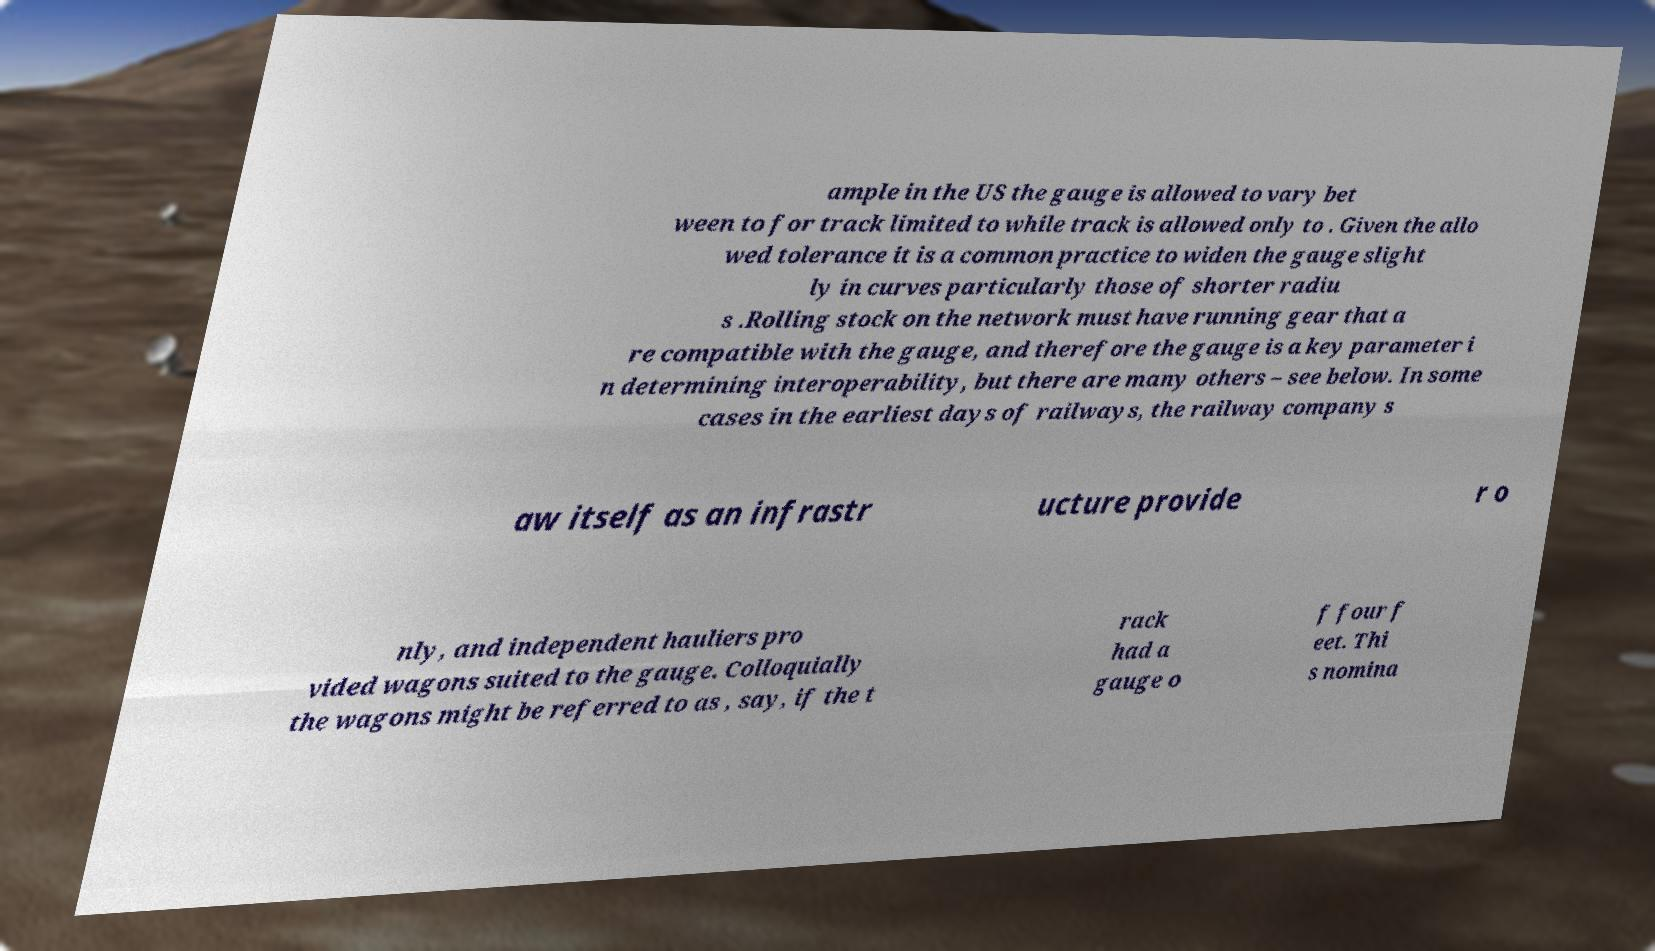Can you accurately transcribe the text from the provided image for me? ample in the US the gauge is allowed to vary bet ween to for track limited to while track is allowed only to . Given the allo wed tolerance it is a common practice to widen the gauge slight ly in curves particularly those of shorter radiu s .Rolling stock on the network must have running gear that a re compatible with the gauge, and therefore the gauge is a key parameter i n determining interoperability, but there are many others – see below. In some cases in the earliest days of railways, the railway company s aw itself as an infrastr ucture provide r o nly, and independent hauliers pro vided wagons suited to the gauge. Colloquially the wagons might be referred to as , say, if the t rack had a gauge o f four f eet. Thi s nomina 